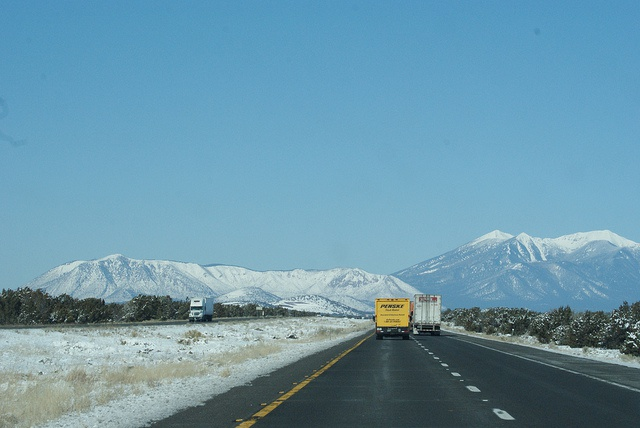Describe the objects in this image and their specific colors. I can see truck in gray, tan, black, and olive tones, truck in gray, darkgray, black, and lightblue tones, and truck in gray, black, and blue tones in this image. 